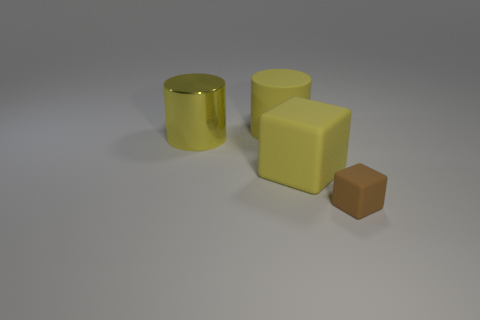Can you compare the sizes of the objects in the image? Certainly! The image displays three objects of varying sizes. The yellow reflective cylindrical object is the tallest and has a circular base. The second-largest is the matte brown cube which has equal dimensions on all sides, making it perfectly cubic. The smallest object is a smaller cube that seems to be made of the same material as the large cylinder, indicating it might be a rubber-like material as well. 